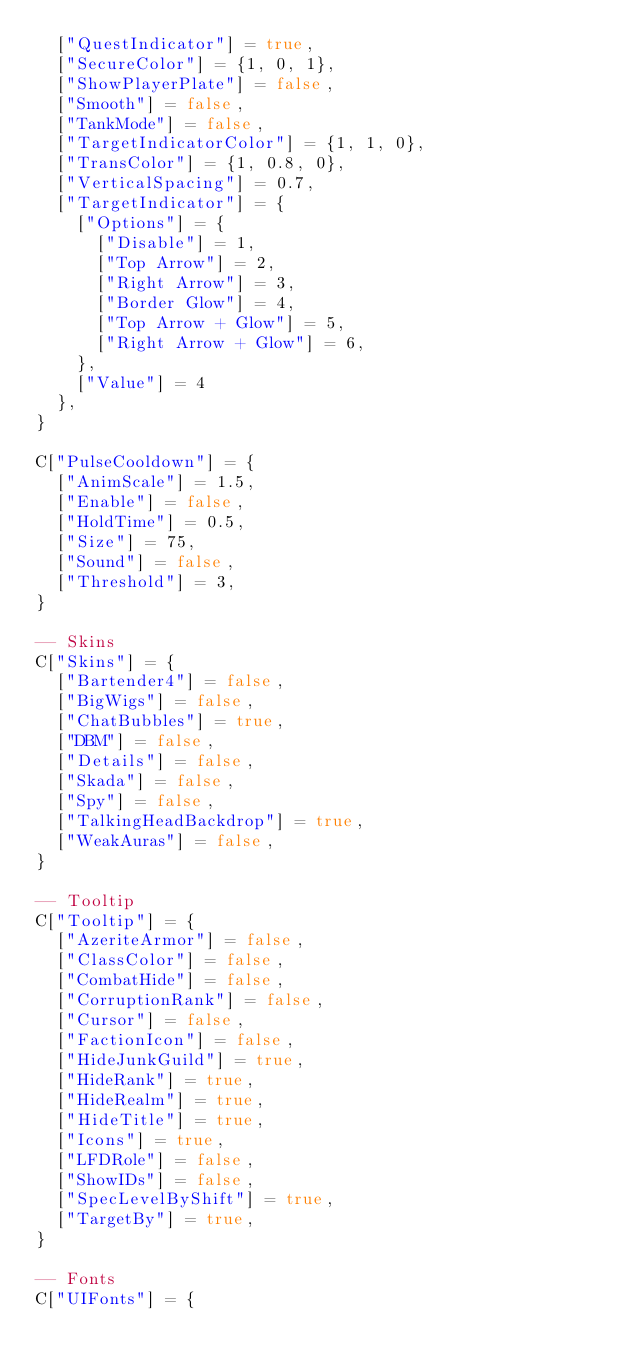<code> <loc_0><loc_0><loc_500><loc_500><_Lua_>	["QuestIndicator"] = true,
	["SecureColor"] = {1, 0, 1},
	["ShowPlayerPlate"] = false,
	["Smooth"] = false,
	["TankMode"] = false,
	["TargetIndicatorColor"] = {1, 1, 0},
	["TransColor"] = {1, 0.8, 0},
	["VerticalSpacing"] = 0.7,
	["TargetIndicator"] = {
		["Options"] = {
			["Disable"] = 1,
			["Top Arrow"] = 2,
			["Right Arrow"] = 3,
			["Border Glow"] = 4,
			["Top Arrow + Glow"] = 5,
			["Right Arrow + Glow"] = 6,
		},
		["Value"] = 4
	},
}

C["PulseCooldown"] = {
	["AnimScale"] = 1.5,
	["Enable"] = false,
	["HoldTime"] = 0.5,
	["Size"] = 75,
	["Sound"] = false,
	["Threshold"] = 3,
}

-- Skins
C["Skins"] = {
	["Bartender4"] = false,
	["BigWigs"] = false,
	["ChatBubbles"] = true,
	["DBM"] = false,
	["Details"] = false,
	["Skada"] = false,
	["Spy"] = false,
	["TalkingHeadBackdrop"] = true,
	["WeakAuras"] = false,
}

-- Tooltip
C["Tooltip"] = {
	["AzeriteArmor"] = false,
	["ClassColor"] = false,
	["CombatHide"] = false,
	["CorruptionRank"] = false,
	["Cursor"] = false,
	["FactionIcon"] = false,
	["HideJunkGuild"] = true,
	["HideRank"] = true,
	["HideRealm"] = true,
	["HideTitle"] = true,
	["Icons"] = true,
	["LFDRole"] = false,
	["ShowIDs"] = false,
	["SpecLevelByShift"] = true,
	["TargetBy"] = true,
}

-- Fonts
C["UIFonts"] = {</code> 